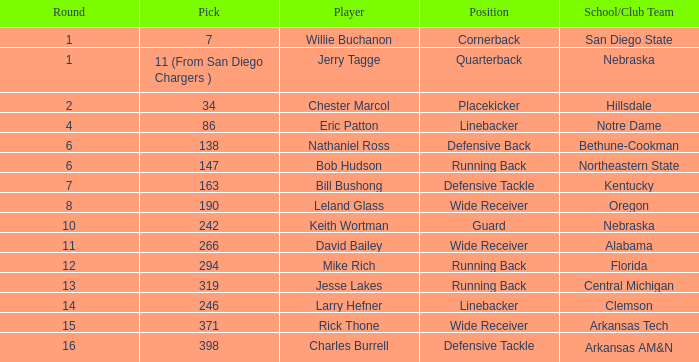Which round has a position that is cornerback? 1.0. 